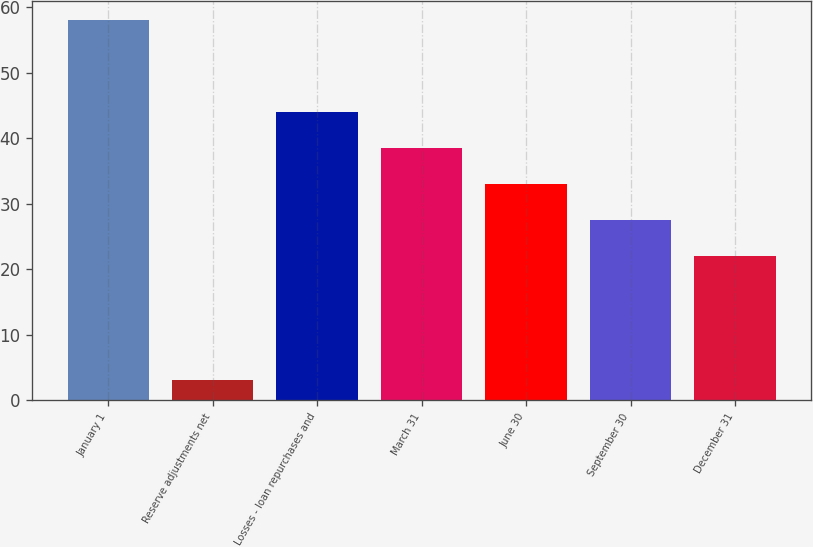<chart> <loc_0><loc_0><loc_500><loc_500><bar_chart><fcel>January 1<fcel>Reserve adjustments net<fcel>Losses - loan repurchases and<fcel>March 31<fcel>June 30<fcel>September 30<fcel>December 31<nl><fcel>58<fcel>3<fcel>44<fcel>38.5<fcel>33<fcel>27.5<fcel>22<nl></chart> 